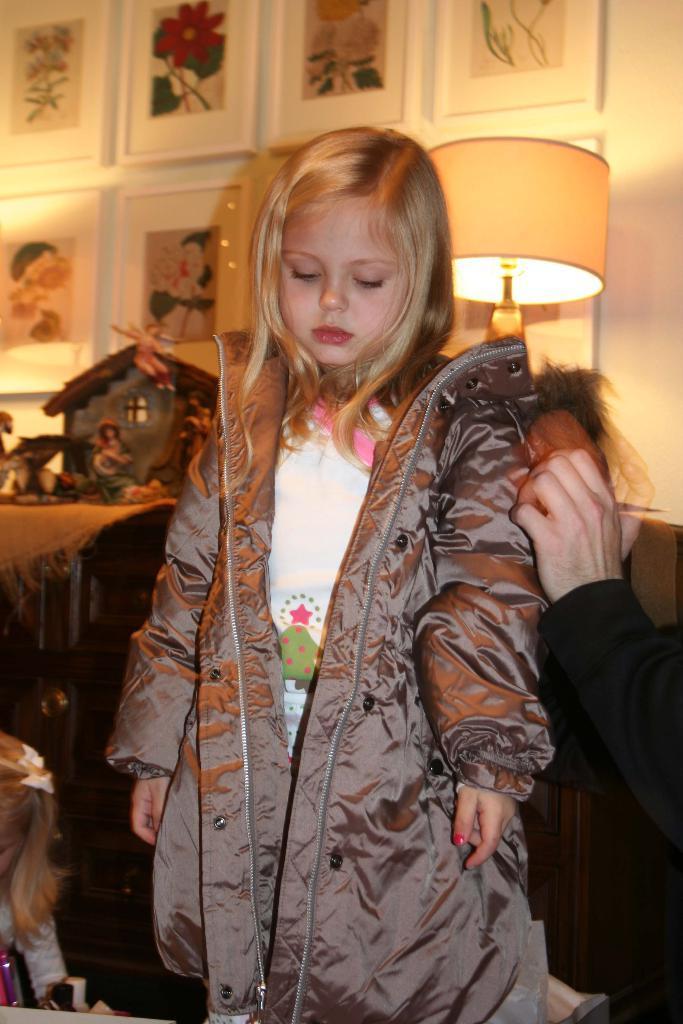Describe this image in one or two sentences. In this picture we can observe a girl. She is wearing jacket which is in brown color. We can observe another girl on the left side. There is a human hand on the right side. We can observe a lamp behind the girl. In the background there are some photo frames fixed to the wall. 